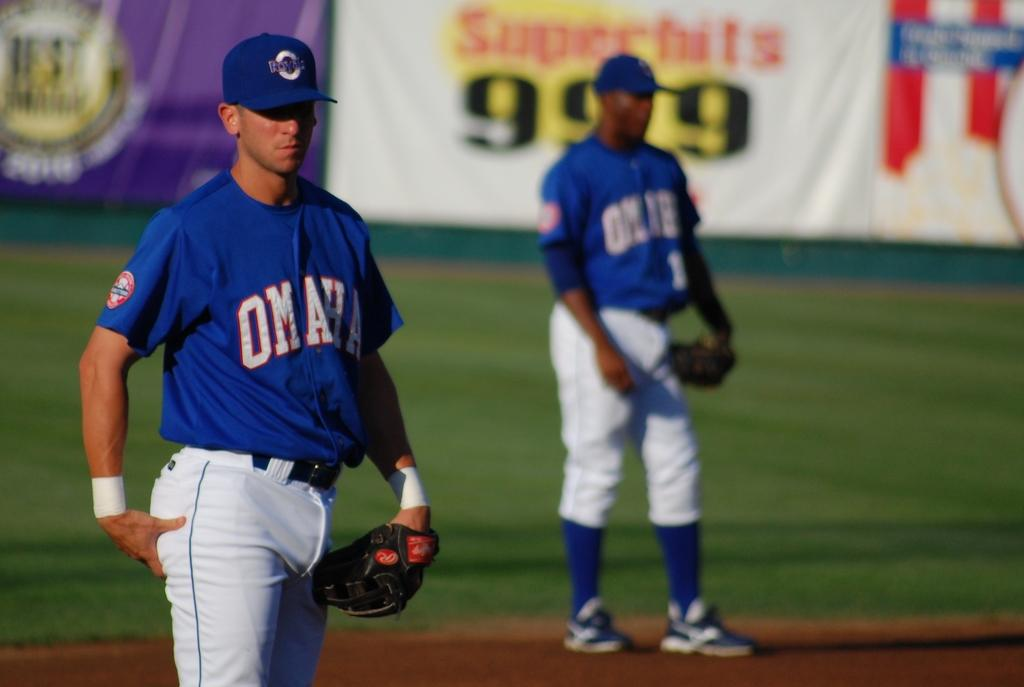<image>
Render a clear and concise summary of the photo. Two baseball players with blue jerseys that say omaha. 